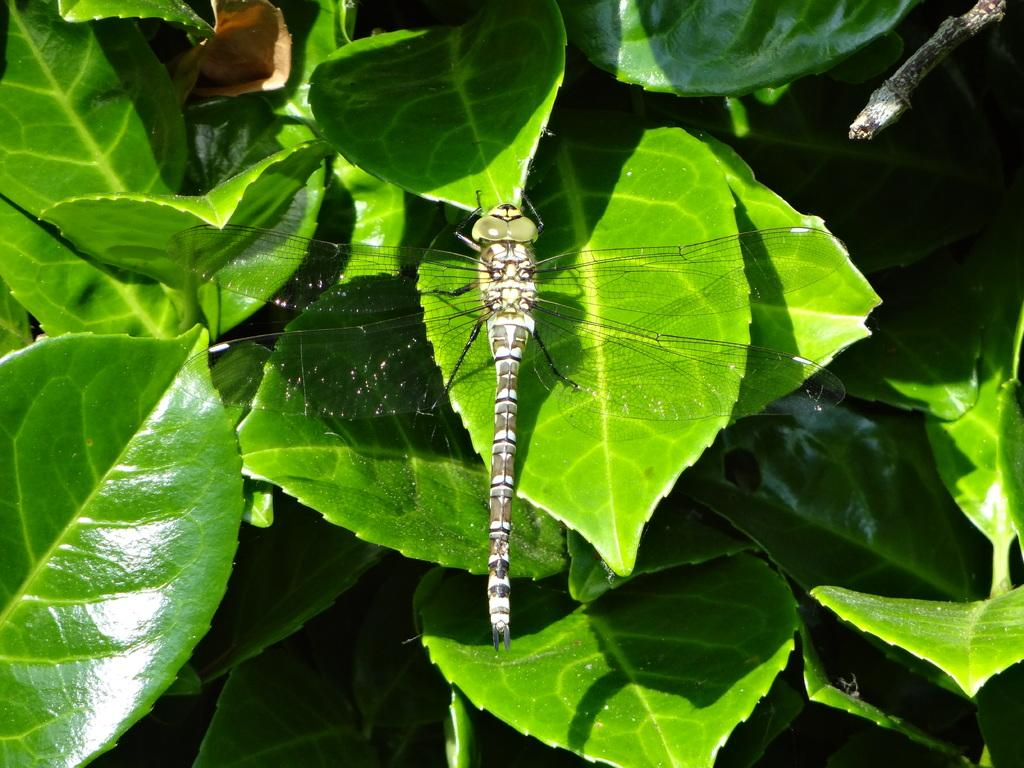What is present in the image? There is an insect in the image. Where is the insect located? The insect is sitting on a leaf. What is the color of the leaf? The leaf is green in color. What can be observed about the insect's appearance? The insect has wide open feathers. Is the insect driving a car in the image? No, the insect is not driving a car in the image. The image only shows an insect sitting on a leaf with wide open feathers. 